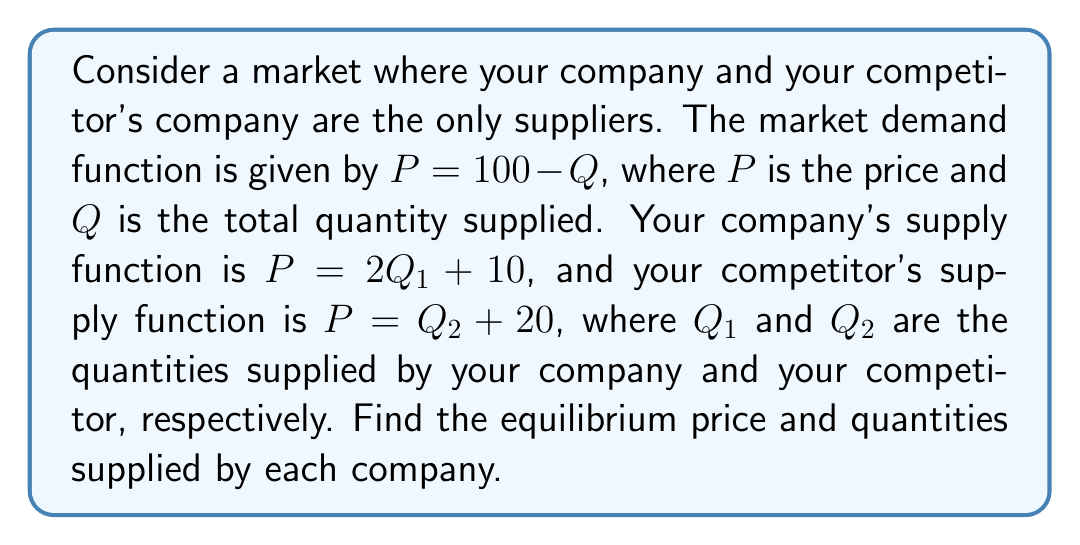Could you help me with this problem? To solve this system of nonlinear equations, we'll follow these steps:

1) First, we know that in equilibrium, the total quantity supplied equals the quantity demanded:
   $Q = Q_1 + Q_2$

2) We can substitute this into the demand function:
   $P = 100 - (Q_1 + Q_2)$

3) Now we have a system of three equations:
   $P = 100 - (Q_1 + Q_2)$  (Demand)
   $P = 2Q_1 + 10$          (Your supply)
   $P = Q_2 + 20$           (Competitor's supply)

4) From your supply equation:
   $Q_1 = \frac{P - 10}{2}$

5) From your competitor's supply equation:
   $Q_2 = P - 20$

6) Substituting these into the demand equation:
   $P = 100 - (\frac{P - 10}{2} + P - 20)$

7) Simplify:
   $P = 100 - \frac{P - 10}{2} - P + 20$
   $P = 120 - \frac{P - 10}{2}$
   $2P = 240 - P + 10$
   $3P = 250$
   $P = \frac{250}{3} \approx 83.33$

8) Now we can find $Q_1$ and $Q_2$:
   $Q_1 = \frac{83.33 - 10}{2} \approx 36.67$
   $Q_2 = 83.33 - 20 \approx 63.33$

9) We can verify that $Q_1 + Q_2 \approx 100 - 83.33 = 16.67$
Answer: $P \approx 83.33$, $Q_1 \approx 36.67$, $Q_2 \approx 63.33$ 